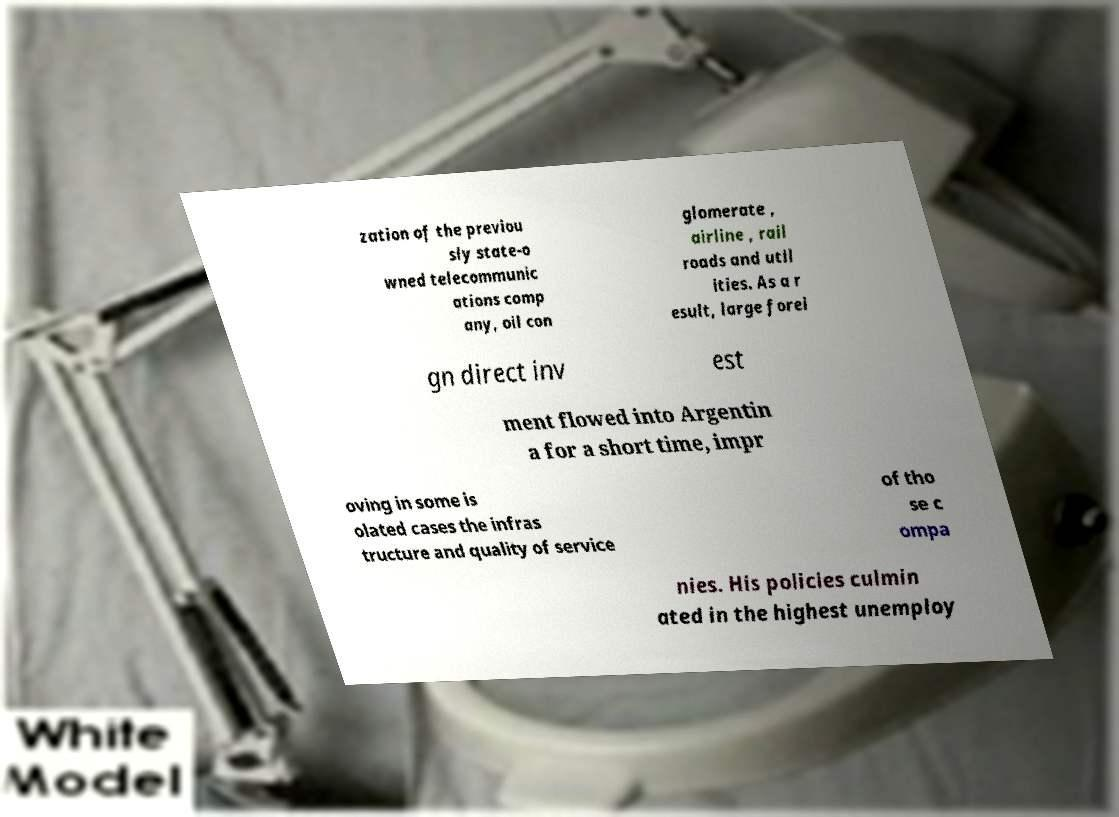Please identify and transcribe the text found in this image. zation of the previou sly state-o wned telecommunic ations comp any, oil con glomerate , airline , rail roads and util ities. As a r esult, large forei gn direct inv est ment flowed into Argentin a for a short time, impr oving in some is olated cases the infras tructure and quality of service of tho se c ompa nies. His policies culmin ated in the highest unemploy 